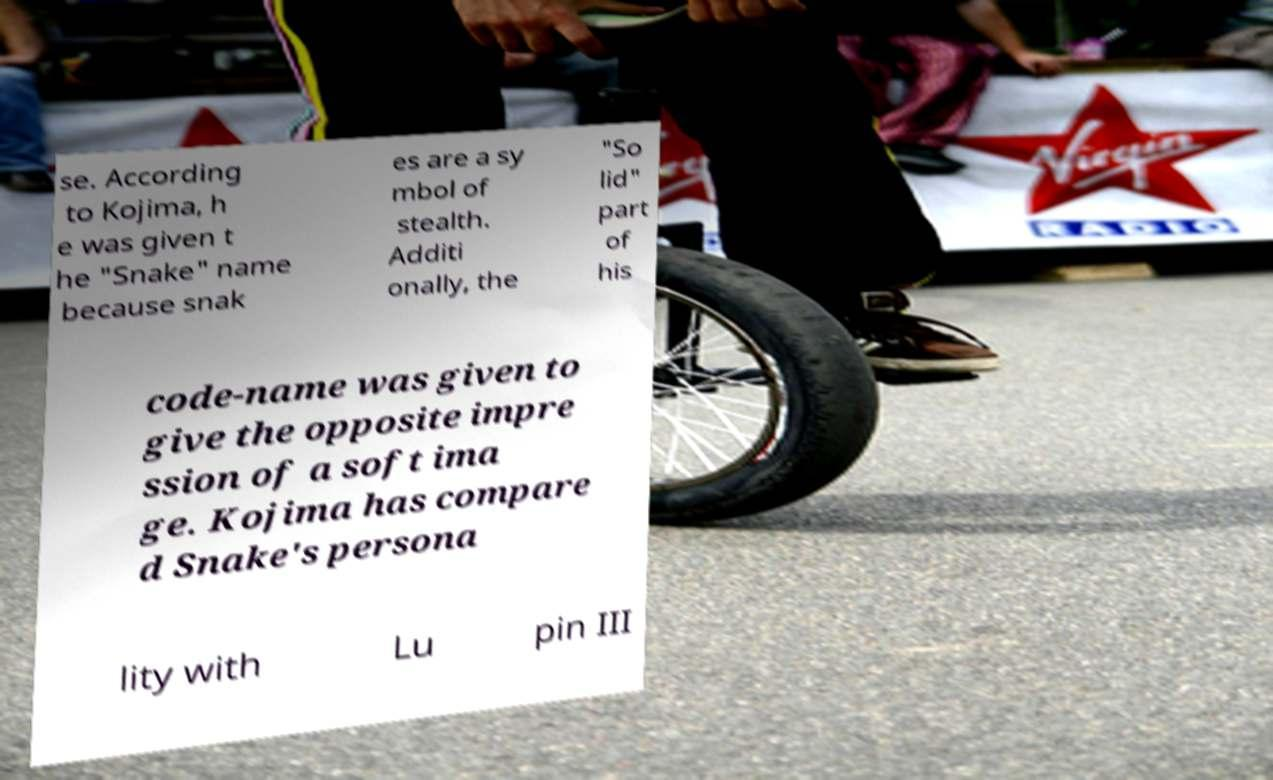There's text embedded in this image that I need extracted. Can you transcribe it verbatim? se. According to Kojima, h e was given t he "Snake" name because snak es are a sy mbol of stealth. Additi onally, the "So lid" part of his code-name was given to give the opposite impre ssion of a soft ima ge. Kojima has compare d Snake's persona lity with Lu pin III 